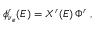<formula> <loc_0><loc_0><loc_500><loc_500>\phi _ { \nu _ { e } } ^ { r } ( E ) = X ^ { r } ( E ) \, \Phi ^ { r } \, ,</formula> 